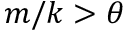Convert formula to latex. <formula><loc_0><loc_0><loc_500><loc_500>m / k > \theta</formula> 